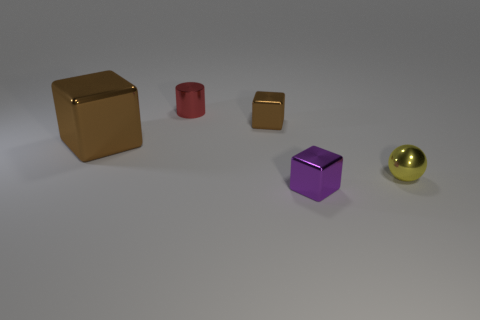Subtract all cyan cylinders. How many brown blocks are left? 2 Subtract all tiny purple blocks. How many blocks are left? 2 Add 2 brown balls. How many objects exist? 7 Subtract 1 blocks. How many blocks are left? 2 Subtract all gray cubes. Subtract all green spheres. How many cubes are left? 3 Subtract all blocks. How many objects are left? 2 Add 3 cubes. How many cubes are left? 6 Add 1 tiny red metal cylinders. How many tiny red metal cylinders exist? 2 Subtract 0 brown cylinders. How many objects are left? 5 Subtract all small red cylinders. Subtract all tiny brown blocks. How many objects are left? 3 